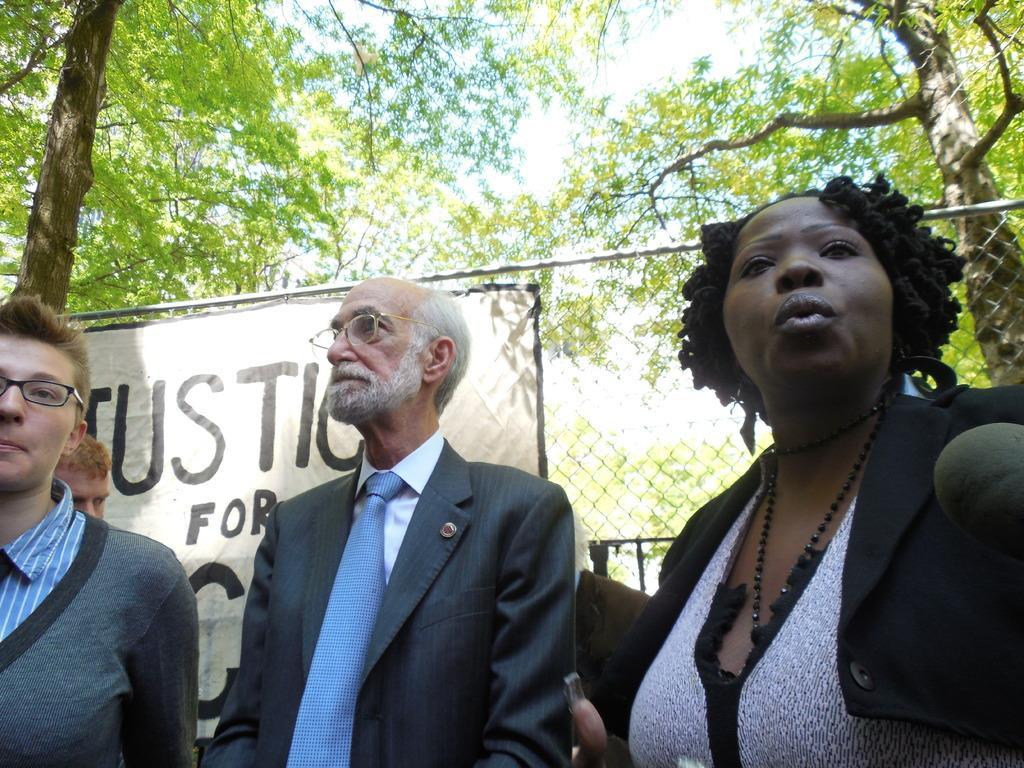Could you give a brief overview of what you see in this image? There are many people. Some are wearing specs. In the back there is a fencing with banner. Also there are trees. 